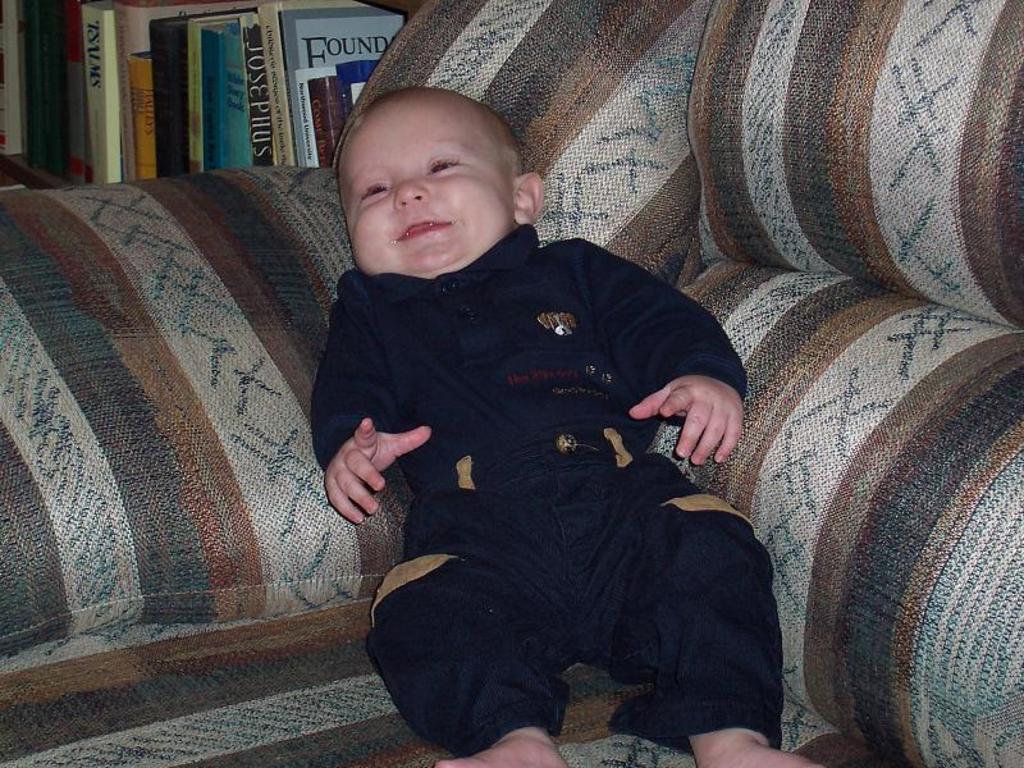How would you summarize this image in a sentence or two? This image is taken indoors. In the background there are many books. In the middle of the image a baby is lying on the couch. 